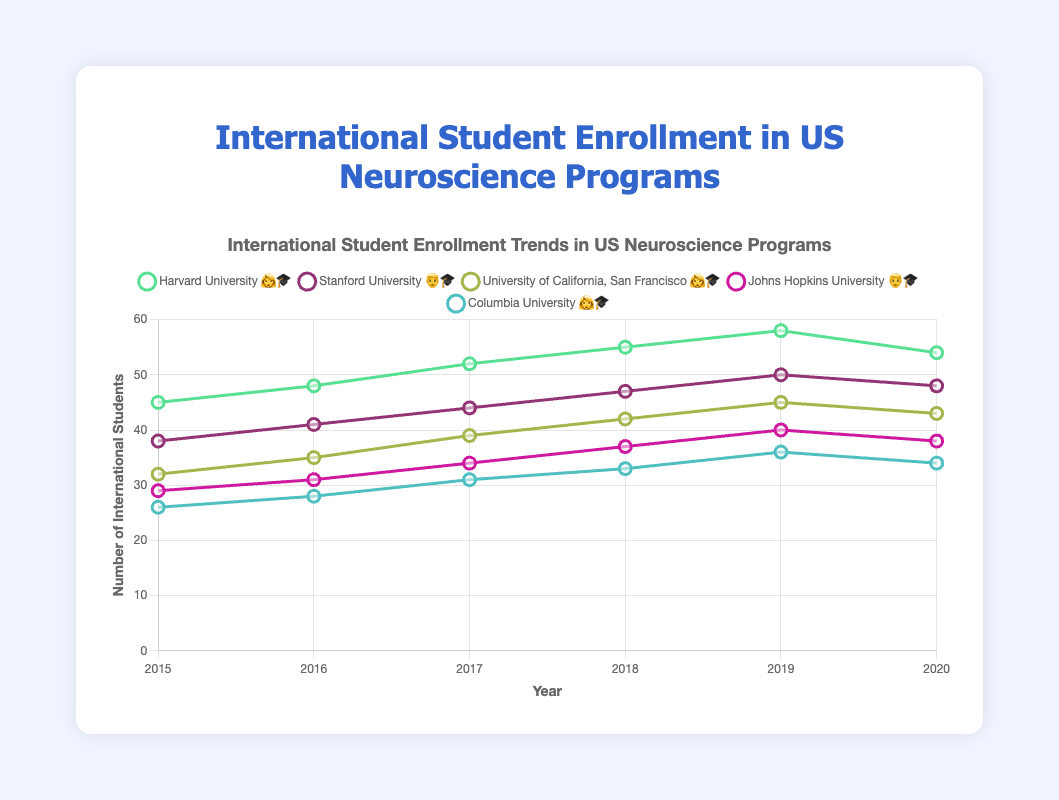How many students were enrolled in Harvard University's neuroscience program in 2020? Look at the Harvard University trend line, then find the 2020 data point.
Answer: 54 What is the overall trend in international student enrollment for Columbia University from 2015 to 2020? Trace the line for Columbia University from 2015 to 2020; it shows a steady increase, then a slight decline in 2020.
Answer: Increasing then declining By how much did Stanford University's international student enrollment increase from 2015 to 2020? Identify the data points for Stanford University in 2015 (38) and 2020 (48), then calculate the difference: 48 - 38.
Answer: 10 Which university had the highest number of international students in 2019? Compare the 2019 data points of all programs. Harvard University had the highest with 58 students.
Answer: Harvard University What is the average number of international students enrolled in Johns Hopkins University's program from 2015 to 2020? Sum the data points of Johns Hopkins University from 2015 to 2020 (29 + 31 + 34 + 37 + 40 + 38 = 209) and then divide by 6 (209/6).
Answer: 34.83 Which programs use the 👩‍🎓 emoji for their students? Examine the legend or labels to see which programs have the 👩‍🎓 emoji next to their name.
Answer: Harvard University, University of California, San Francisco, Columbia University In which year did Harvard University experience a decline in international student enrollment? Look at the Harvard University enrollment trend and identify the year when the number decreased: 2020 (from 58 to 54).
Answer: 2020 What was the combined total number of international students in Stanford University and Johns Hopkins University in 2018? Sum the 2018 enrollment for Stanford (47) and Johns Hopkins (37): 47 + 37.
Answer: 84 Which university had the smallest enrollment trend variation from 2015 to 2020? Calculate the range (max-min) of enrollment for each university. Columbia University's smallest variation (36-26=10).
Answer: Columbia University How does the enrollment trend of University of California, San Francisco compare to that of Stanford University from 2015 to 2020? Compare their trends year by year; both show a generally increasing trend, but Stanford's increases were slightly larger.
Answer: Similar but Stanford's increases are larger 